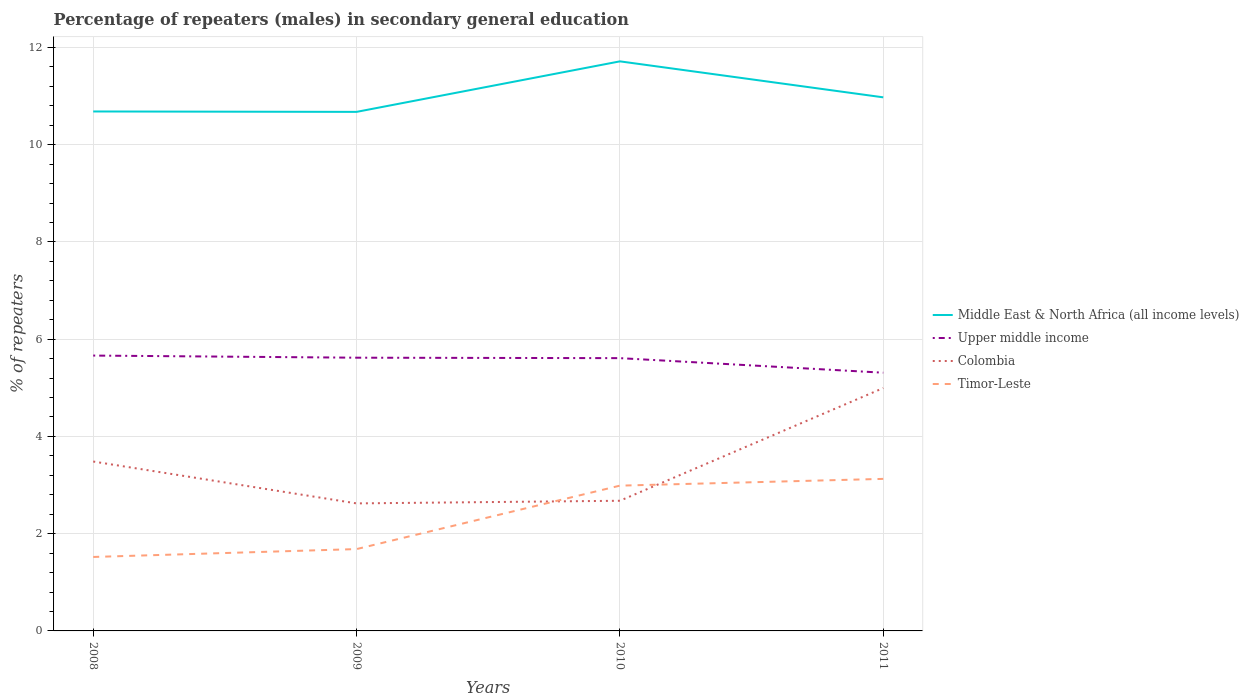How many different coloured lines are there?
Give a very brief answer. 4. Across all years, what is the maximum percentage of male repeaters in Colombia?
Provide a short and direct response. 2.62. In which year was the percentage of male repeaters in Colombia maximum?
Offer a terse response. 2009. What is the total percentage of male repeaters in Colombia in the graph?
Your answer should be very brief. -1.51. What is the difference between the highest and the second highest percentage of male repeaters in Upper middle income?
Ensure brevity in your answer.  0.35. What is the difference between the highest and the lowest percentage of male repeaters in Colombia?
Keep it short and to the point. 2. How many lines are there?
Provide a short and direct response. 4. What is the difference between two consecutive major ticks on the Y-axis?
Offer a very short reply. 2. Does the graph contain any zero values?
Offer a very short reply. No. Where does the legend appear in the graph?
Your answer should be compact. Center right. How many legend labels are there?
Make the answer very short. 4. What is the title of the graph?
Offer a very short reply. Percentage of repeaters (males) in secondary general education. Does "Heavily indebted poor countries" appear as one of the legend labels in the graph?
Provide a succinct answer. No. What is the label or title of the Y-axis?
Your response must be concise. % of repeaters. What is the % of repeaters of Middle East & North Africa (all income levels) in 2008?
Offer a very short reply. 10.68. What is the % of repeaters in Upper middle income in 2008?
Provide a succinct answer. 5.66. What is the % of repeaters of Colombia in 2008?
Provide a succinct answer. 3.48. What is the % of repeaters of Timor-Leste in 2008?
Make the answer very short. 1.52. What is the % of repeaters in Middle East & North Africa (all income levels) in 2009?
Give a very brief answer. 10.68. What is the % of repeaters in Upper middle income in 2009?
Your answer should be very brief. 5.62. What is the % of repeaters in Colombia in 2009?
Give a very brief answer. 2.62. What is the % of repeaters of Timor-Leste in 2009?
Provide a short and direct response. 1.68. What is the % of repeaters in Middle East & North Africa (all income levels) in 2010?
Offer a very short reply. 11.71. What is the % of repeaters in Upper middle income in 2010?
Provide a succinct answer. 5.61. What is the % of repeaters of Colombia in 2010?
Make the answer very short. 2.68. What is the % of repeaters in Timor-Leste in 2010?
Your answer should be compact. 2.99. What is the % of repeaters in Middle East & North Africa (all income levels) in 2011?
Give a very brief answer. 10.97. What is the % of repeaters of Upper middle income in 2011?
Provide a succinct answer. 5.31. What is the % of repeaters in Colombia in 2011?
Offer a terse response. 4.99. What is the % of repeaters of Timor-Leste in 2011?
Give a very brief answer. 3.13. Across all years, what is the maximum % of repeaters in Middle East & North Africa (all income levels)?
Your answer should be compact. 11.71. Across all years, what is the maximum % of repeaters of Upper middle income?
Provide a short and direct response. 5.66. Across all years, what is the maximum % of repeaters in Colombia?
Your response must be concise. 4.99. Across all years, what is the maximum % of repeaters in Timor-Leste?
Keep it short and to the point. 3.13. Across all years, what is the minimum % of repeaters of Middle East & North Africa (all income levels)?
Make the answer very short. 10.68. Across all years, what is the minimum % of repeaters in Upper middle income?
Give a very brief answer. 5.31. Across all years, what is the minimum % of repeaters of Colombia?
Your answer should be very brief. 2.62. Across all years, what is the minimum % of repeaters of Timor-Leste?
Provide a succinct answer. 1.52. What is the total % of repeaters in Middle East & North Africa (all income levels) in the graph?
Provide a short and direct response. 44.05. What is the total % of repeaters in Upper middle income in the graph?
Keep it short and to the point. 22.2. What is the total % of repeaters in Colombia in the graph?
Your answer should be very brief. 13.78. What is the total % of repeaters in Timor-Leste in the graph?
Offer a very short reply. 9.32. What is the difference between the % of repeaters of Middle East & North Africa (all income levels) in 2008 and that in 2009?
Give a very brief answer. 0.01. What is the difference between the % of repeaters of Upper middle income in 2008 and that in 2009?
Keep it short and to the point. 0.04. What is the difference between the % of repeaters of Colombia in 2008 and that in 2009?
Your response must be concise. 0.86. What is the difference between the % of repeaters in Timor-Leste in 2008 and that in 2009?
Your answer should be very brief. -0.16. What is the difference between the % of repeaters in Middle East & North Africa (all income levels) in 2008 and that in 2010?
Your answer should be very brief. -1.03. What is the difference between the % of repeaters in Upper middle income in 2008 and that in 2010?
Ensure brevity in your answer.  0.05. What is the difference between the % of repeaters of Colombia in 2008 and that in 2010?
Your answer should be very brief. 0.81. What is the difference between the % of repeaters in Timor-Leste in 2008 and that in 2010?
Your response must be concise. -1.47. What is the difference between the % of repeaters in Middle East & North Africa (all income levels) in 2008 and that in 2011?
Provide a succinct answer. -0.29. What is the difference between the % of repeaters in Upper middle income in 2008 and that in 2011?
Ensure brevity in your answer.  0.35. What is the difference between the % of repeaters of Colombia in 2008 and that in 2011?
Offer a terse response. -1.51. What is the difference between the % of repeaters in Timor-Leste in 2008 and that in 2011?
Make the answer very short. -1.61. What is the difference between the % of repeaters in Middle East & North Africa (all income levels) in 2009 and that in 2010?
Your answer should be very brief. -1.04. What is the difference between the % of repeaters in Upper middle income in 2009 and that in 2010?
Keep it short and to the point. 0.01. What is the difference between the % of repeaters of Colombia in 2009 and that in 2010?
Your response must be concise. -0.05. What is the difference between the % of repeaters of Timor-Leste in 2009 and that in 2010?
Give a very brief answer. -1.3. What is the difference between the % of repeaters in Middle East & North Africa (all income levels) in 2009 and that in 2011?
Ensure brevity in your answer.  -0.3. What is the difference between the % of repeaters in Upper middle income in 2009 and that in 2011?
Your answer should be compact. 0.31. What is the difference between the % of repeaters in Colombia in 2009 and that in 2011?
Give a very brief answer. -2.37. What is the difference between the % of repeaters in Timor-Leste in 2009 and that in 2011?
Keep it short and to the point. -1.44. What is the difference between the % of repeaters of Middle East & North Africa (all income levels) in 2010 and that in 2011?
Ensure brevity in your answer.  0.74. What is the difference between the % of repeaters of Upper middle income in 2010 and that in 2011?
Make the answer very short. 0.3. What is the difference between the % of repeaters of Colombia in 2010 and that in 2011?
Ensure brevity in your answer.  -2.32. What is the difference between the % of repeaters of Timor-Leste in 2010 and that in 2011?
Offer a very short reply. -0.14. What is the difference between the % of repeaters in Middle East & North Africa (all income levels) in 2008 and the % of repeaters in Upper middle income in 2009?
Your answer should be compact. 5.06. What is the difference between the % of repeaters in Middle East & North Africa (all income levels) in 2008 and the % of repeaters in Colombia in 2009?
Make the answer very short. 8.06. What is the difference between the % of repeaters in Middle East & North Africa (all income levels) in 2008 and the % of repeaters in Timor-Leste in 2009?
Your response must be concise. 9. What is the difference between the % of repeaters in Upper middle income in 2008 and the % of repeaters in Colombia in 2009?
Provide a short and direct response. 3.04. What is the difference between the % of repeaters of Upper middle income in 2008 and the % of repeaters of Timor-Leste in 2009?
Provide a succinct answer. 3.98. What is the difference between the % of repeaters of Colombia in 2008 and the % of repeaters of Timor-Leste in 2009?
Your answer should be compact. 1.8. What is the difference between the % of repeaters in Middle East & North Africa (all income levels) in 2008 and the % of repeaters in Upper middle income in 2010?
Keep it short and to the point. 5.07. What is the difference between the % of repeaters of Middle East & North Africa (all income levels) in 2008 and the % of repeaters of Colombia in 2010?
Your answer should be compact. 8.01. What is the difference between the % of repeaters in Middle East & North Africa (all income levels) in 2008 and the % of repeaters in Timor-Leste in 2010?
Give a very brief answer. 7.7. What is the difference between the % of repeaters of Upper middle income in 2008 and the % of repeaters of Colombia in 2010?
Offer a terse response. 2.99. What is the difference between the % of repeaters in Upper middle income in 2008 and the % of repeaters in Timor-Leste in 2010?
Your answer should be compact. 2.68. What is the difference between the % of repeaters in Colombia in 2008 and the % of repeaters in Timor-Leste in 2010?
Your response must be concise. 0.5. What is the difference between the % of repeaters of Middle East & North Africa (all income levels) in 2008 and the % of repeaters of Upper middle income in 2011?
Make the answer very short. 5.37. What is the difference between the % of repeaters of Middle East & North Africa (all income levels) in 2008 and the % of repeaters of Colombia in 2011?
Offer a very short reply. 5.69. What is the difference between the % of repeaters of Middle East & North Africa (all income levels) in 2008 and the % of repeaters of Timor-Leste in 2011?
Provide a succinct answer. 7.56. What is the difference between the % of repeaters of Upper middle income in 2008 and the % of repeaters of Colombia in 2011?
Provide a short and direct response. 0.67. What is the difference between the % of repeaters in Upper middle income in 2008 and the % of repeaters in Timor-Leste in 2011?
Your response must be concise. 2.54. What is the difference between the % of repeaters of Colombia in 2008 and the % of repeaters of Timor-Leste in 2011?
Your answer should be compact. 0.36. What is the difference between the % of repeaters of Middle East & North Africa (all income levels) in 2009 and the % of repeaters of Upper middle income in 2010?
Your answer should be very brief. 5.06. What is the difference between the % of repeaters of Middle East & North Africa (all income levels) in 2009 and the % of repeaters of Colombia in 2010?
Make the answer very short. 8. What is the difference between the % of repeaters in Middle East & North Africa (all income levels) in 2009 and the % of repeaters in Timor-Leste in 2010?
Offer a very short reply. 7.69. What is the difference between the % of repeaters in Upper middle income in 2009 and the % of repeaters in Colombia in 2010?
Provide a succinct answer. 2.94. What is the difference between the % of repeaters of Upper middle income in 2009 and the % of repeaters of Timor-Leste in 2010?
Give a very brief answer. 2.63. What is the difference between the % of repeaters in Colombia in 2009 and the % of repeaters in Timor-Leste in 2010?
Make the answer very short. -0.37. What is the difference between the % of repeaters of Middle East & North Africa (all income levels) in 2009 and the % of repeaters of Upper middle income in 2011?
Give a very brief answer. 5.36. What is the difference between the % of repeaters in Middle East & North Africa (all income levels) in 2009 and the % of repeaters in Colombia in 2011?
Your response must be concise. 5.68. What is the difference between the % of repeaters of Middle East & North Africa (all income levels) in 2009 and the % of repeaters of Timor-Leste in 2011?
Offer a terse response. 7.55. What is the difference between the % of repeaters in Upper middle income in 2009 and the % of repeaters in Colombia in 2011?
Offer a very short reply. 0.62. What is the difference between the % of repeaters of Upper middle income in 2009 and the % of repeaters of Timor-Leste in 2011?
Ensure brevity in your answer.  2.49. What is the difference between the % of repeaters in Colombia in 2009 and the % of repeaters in Timor-Leste in 2011?
Provide a succinct answer. -0.5. What is the difference between the % of repeaters of Middle East & North Africa (all income levels) in 2010 and the % of repeaters of Upper middle income in 2011?
Provide a short and direct response. 6.4. What is the difference between the % of repeaters of Middle East & North Africa (all income levels) in 2010 and the % of repeaters of Colombia in 2011?
Ensure brevity in your answer.  6.72. What is the difference between the % of repeaters in Middle East & North Africa (all income levels) in 2010 and the % of repeaters in Timor-Leste in 2011?
Your answer should be compact. 8.59. What is the difference between the % of repeaters of Upper middle income in 2010 and the % of repeaters of Colombia in 2011?
Ensure brevity in your answer.  0.62. What is the difference between the % of repeaters of Upper middle income in 2010 and the % of repeaters of Timor-Leste in 2011?
Offer a terse response. 2.48. What is the difference between the % of repeaters of Colombia in 2010 and the % of repeaters of Timor-Leste in 2011?
Your answer should be very brief. -0.45. What is the average % of repeaters of Middle East & North Africa (all income levels) per year?
Offer a terse response. 11.01. What is the average % of repeaters of Upper middle income per year?
Provide a short and direct response. 5.55. What is the average % of repeaters in Colombia per year?
Your answer should be very brief. 3.44. What is the average % of repeaters of Timor-Leste per year?
Your answer should be compact. 2.33. In the year 2008, what is the difference between the % of repeaters in Middle East & North Africa (all income levels) and % of repeaters in Upper middle income?
Your response must be concise. 5.02. In the year 2008, what is the difference between the % of repeaters of Middle East & North Africa (all income levels) and % of repeaters of Colombia?
Your response must be concise. 7.2. In the year 2008, what is the difference between the % of repeaters of Middle East & North Africa (all income levels) and % of repeaters of Timor-Leste?
Your response must be concise. 9.16. In the year 2008, what is the difference between the % of repeaters in Upper middle income and % of repeaters in Colombia?
Give a very brief answer. 2.18. In the year 2008, what is the difference between the % of repeaters in Upper middle income and % of repeaters in Timor-Leste?
Ensure brevity in your answer.  4.14. In the year 2008, what is the difference between the % of repeaters in Colombia and % of repeaters in Timor-Leste?
Make the answer very short. 1.96. In the year 2009, what is the difference between the % of repeaters in Middle East & North Africa (all income levels) and % of repeaters in Upper middle income?
Your answer should be very brief. 5.06. In the year 2009, what is the difference between the % of repeaters in Middle East & North Africa (all income levels) and % of repeaters in Colombia?
Offer a very short reply. 8.05. In the year 2009, what is the difference between the % of repeaters in Middle East & North Africa (all income levels) and % of repeaters in Timor-Leste?
Your answer should be compact. 8.99. In the year 2009, what is the difference between the % of repeaters in Upper middle income and % of repeaters in Colombia?
Offer a terse response. 3. In the year 2009, what is the difference between the % of repeaters of Upper middle income and % of repeaters of Timor-Leste?
Your answer should be compact. 3.94. In the year 2009, what is the difference between the % of repeaters in Colombia and % of repeaters in Timor-Leste?
Keep it short and to the point. 0.94. In the year 2010, what is the difference between the % of repeaters of Middle East & North Africa (all income levels) and % of repeaters of Upper middle income?
Offer a terse response. 6.1. In the year 2010, what is the difference between the % of repeaters of Middle East & North Africa (all income levels) and % of repeaters of Colombia?
Your answer should be compact. 9.04. In the year 2010, what is the difference between the % of repeaters in Middle East & North Africa (all income levels) and % of repeaters in Timor-Leste?
Provide a succinct answer. 8.73. In the year 2010, what is the difference between the % of repeaters of Upper middle income and % of repeaters of Colombia?
Your answer should be very brief. 2.93. In the year 2010, what is the difference between the % of repeaters of Upper middle income and % of repeaters of Timor-Leste?
Provide a succinct answer. 2.62. In the year 2010, what is the difference between the % of repeaters of Colombia and % of repeaters of Timor-Leste?
Your answer should be compact. -0.31. In the year 2011, what is the difference between the % of repeaters of Middle East & North Africa (all income levels) and % of repeaters of Upper middle income?
Your answer should be very brief. 5.66. In the year 2011, what is the difference between the % of repeaters of Middle East & North Africa (all income levels) and % of repeaters of Colombia?
Provide a short and direct response. 5.98. In the year 2011, what is the difference between the % of repeaters of Middle East & North Africa (all income levels) and % of repeaters of Timor-Leste?
Offer a terse response. 7.85. In the year 2011, what is the difference between the % of repeaters in Upper middle income and % of repeaters in Colombia?
Your answer should be compact. 0.32. In the year 2011, what is the difference between the % of repeaters in Upper middle income and % of repeaters in Timor-Leste?
Provide a succinct answer. 2.18. In the year 2011, what is the difference between the % of repeaters of Colombia and % of repeaters of Timor-Leste?
Make the answer very short. 1.87. What is the ratio of the % of repeaters in Upper middle income in 2008 to that in 2009?
Give a very brief answer. 1.01. What is the ratio of the % of repeaters in Colombia in 2008 to that in 2009?
Give a very brief answer. 1.33. What is the ratio of the % of repeaters of Timor-Leste in 2008 to that in 2009?
Offer a terse response. 0.9. What is the ratio of the % of repeaters of Middle East & North Africa (all income levels) in 2008 to that in 2010?
Keep it short and to the point. 0.91. What is the ratio of the % of repeaters in Upper middle income in 2008 to that in 2010?
Provide a succinct answer. 1.01. What is the ratio of the % of repeaters in Colombia in 2008 to that in 2010?
Give a very brief answer. 1.3. What is the ratio of the % of repeaters in Timor-Leste in 2008 to that in 2010?
Make the answer very short. 0.51. What is the ratio of the % of repeaters in Middle East & North Africa (all income levels) in 2008 to that in 2011?
Provide a succinct answer. 0.97. What is the ratio of the % of repeaters of Upper middle income in 2008 to that in 2011?
Make the answer very short. 1.07. What is the ratio of the % of repeaters in Colombia in 2008 to that in 2011?
Provide a succinct answer. 0.7. What is the ratio of the % of repeaters of Timor-Leste in 2008 to that in 2011?
Your answer should be very brief. 0.49. What is the ratio of the % of repeaters in Middle East & North Africa (all income levels) in 2009 to that in 2010?
Give a very brief answer. 0.91. What is the ratio of the % of repeaters of Upper middle income in 2009 to that in 2010?
Your response must be concise. 1. What is the ratio of the % of repeaters of Colombia in 2009 to that in 2010?
Provide a short and direct response. 0.98. What is the ratio of the % of repeaters in Timor-Leste in 2009 to that in 2010?
Give a very brief answer. 0.56. What is the ratio of the % of repeaters of Middle East & North Africa (all income levels) in 2009 to that in 2011?
Provide a succinct answer. 0.97. What is the ratio of the % of repeaters in Upper middle income in 2009 to that in 2011?
Offer a very short reply. 1.06. What is the ratio of the % of repeaters of Colombia in 2009 to that in 2011?
Your response must be concise. 0.53. What is the ratio of the % of repeaters of Timor-Leste in 2009 to that in 2011?
Your answer should be compact. 0.54. What is the ratio of the % of repeaters in Middle East & North Africa (all income levels) in 2010 to that in 2011?
Your answer should be very brief. 1.07. What is the ratio of the % of repeaters of Upper middle income in 2010 to that in 2011?
Your answer should be compact. 1.06. What is the ratio of the % of repeaters of Colombia in 2010 to that in 2011?
Offer a terse response. 0.54. What is the ratio of the % of repeaters of Timor-Leste in 2010 to that in 2011?
Offer a very short reply. 0.96. What is the difference between the highest and the second highest % of repeaters of Middle East & North Africa (all income levels)?
Your answer should be compact. 0.74. What is the difference between the highest and the second highest % of repeaters of Upper middle income?
Provide a succinct answer. 0.04. What is the difference between the highest and the second highest % of repeaters of Colombia?
Your response must be concise. 1.51. What is the difference between the highest and the second highest % of repeaters of Timor-Leste?
Provide a short and direct response. 0.14. What is the difference between the highest and the lowest % of repeaters of Middle East & North Africa (all income levels)?
Your answer should be very brief. 1.04. What is the difference between the highest and the lowest % of repeaters of Upper middle income?
Your response must be concise. 0.35. What is the difference between the highest and the lowest % of repeaters in Colombia?
Keep it short and to the point. 2.37. What is the difference between the highest and the lowest % of repeaters of Timor-Leste?
Keep it short and to the point. 1.61. 